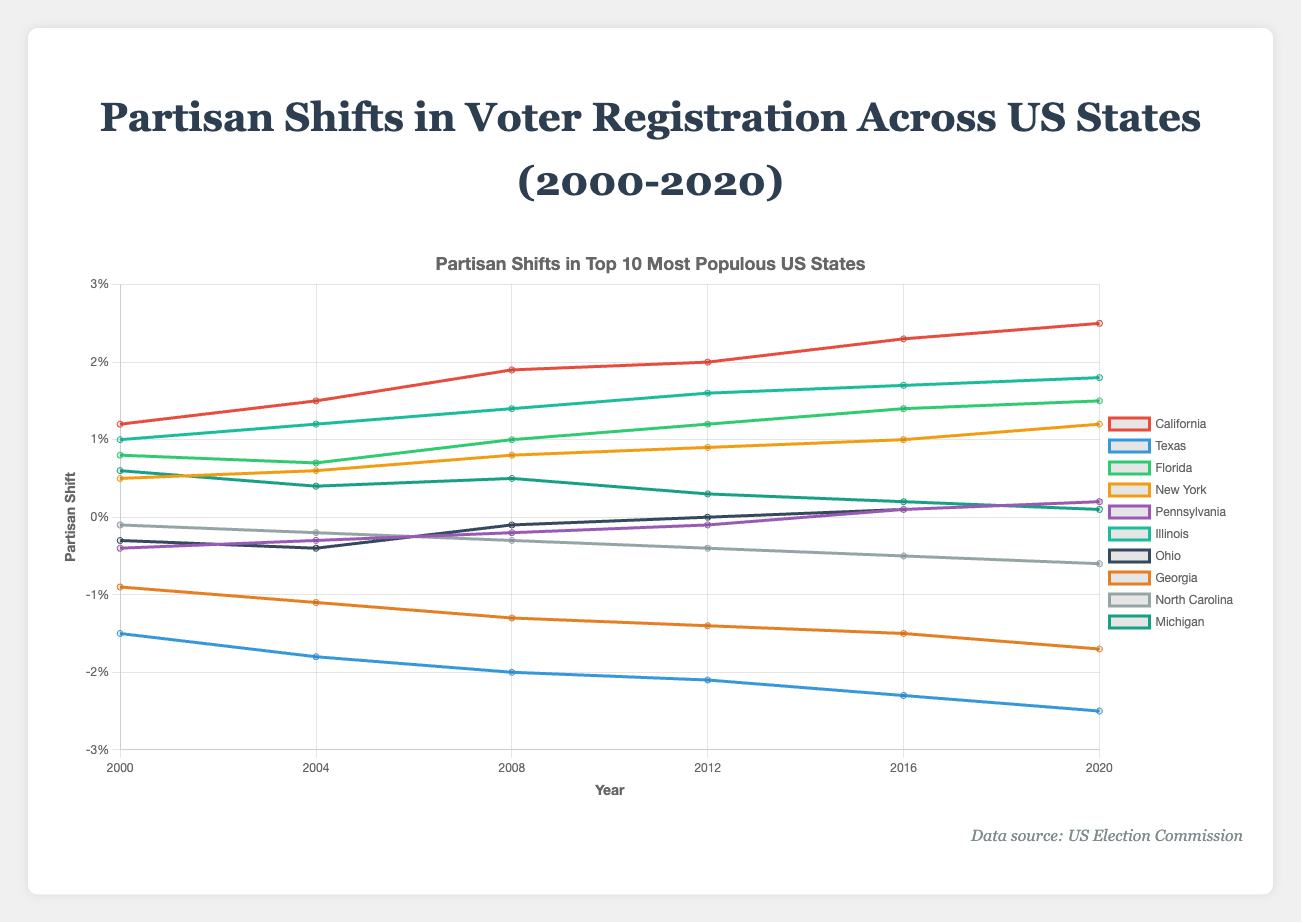What's the overall trend in partisan shift for California from 2000 to 2020? Over the time period from 2000 to 2020, the partisan shift in California has steadily increased from 1.2% to 2.5%. We can observe that the values in the dataset for California increase consistently over the years.
Answer: Increasing trend How does the partisan shift in Texas in 2020 compare to that in 2000? In 2020, the partisan shift in Texas is -2.5%, whereas in 2000 it was -1.5%. By comparing these values, we see an increase in the negative shift by 1%.
Answer: More negative by 1% Which state had the biggest positive change in partisan shift from 2000 to 2020? By examining the changes for each state between 2000 and 2020, California has the largest positive change from 1.2% to 2.5%, resulting in a change of 1.3%.
Answer: California What is the contrast in partisan shifts between Ohio and Michigan in 2008? In 2008, Ohio had a partisan shift of -0.1%, while Michigan had a shift of 0.5%. The difference between Ohio and Michigan is 0.6%.
Answer: Difference of 0.6% Which state showed the most consistent trend in partisan shift from 2000 to 2020? Both New York and Illinois consistently show an increasing trend each year with no fluctuation in the direction of their shifts. However, Illinois increased consistently from 1.0% to 1.8%, while New York moved from 0.5% to 1.2%.
Answer: Illinois In 2016, which state had the closest partisan shift to zero? In 2016, the state with the partisan shift closest to zero is Pennsylvania with a shift of 0.1%.
Answer: Pennsylvania What's the average partisan shift in Florida between 2000 and 2020? To find the average, sum up the values from the dataset for Florida (0.8 + 0.7 + 1.0 + 1.2 + 1.4 + 1.5) = 6.6, then divide by the number of data points (6). The average is 6.6/6 ≈ 1.1.
Answer: 1.1 Which state had the most negative partisan shift in any given year and what year was it? Texas had the most negative partisan shift of -2.5% in the year 2020 according to the data presented.
Answer: Texas in 2020 How did the partisan shift in Pennsylvania change from 2008 to 2012 compared to Michigan? From 2008 to 2012, Pennsylvania's partisan shift changed from -0.2 to -0.1 (an increase of 0.1), while Michigan's shift changed from 0.5 to 0.3 (a decrease of 0.2).
Answer: Pennsylvania increased by 0.1, Michigan decreased by 0.2 